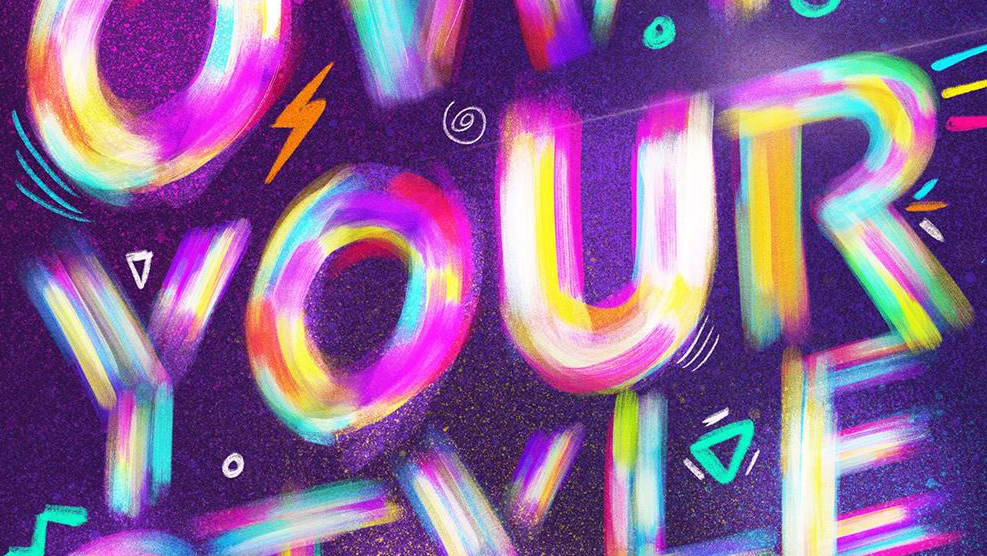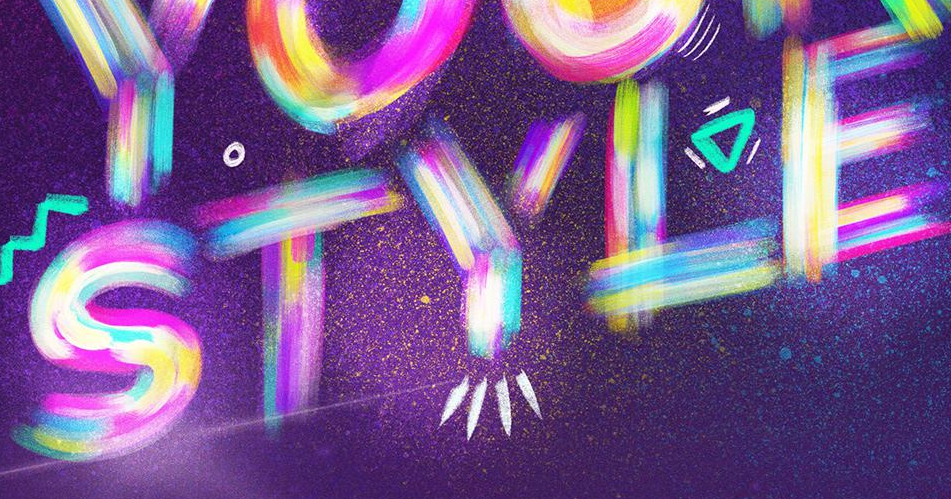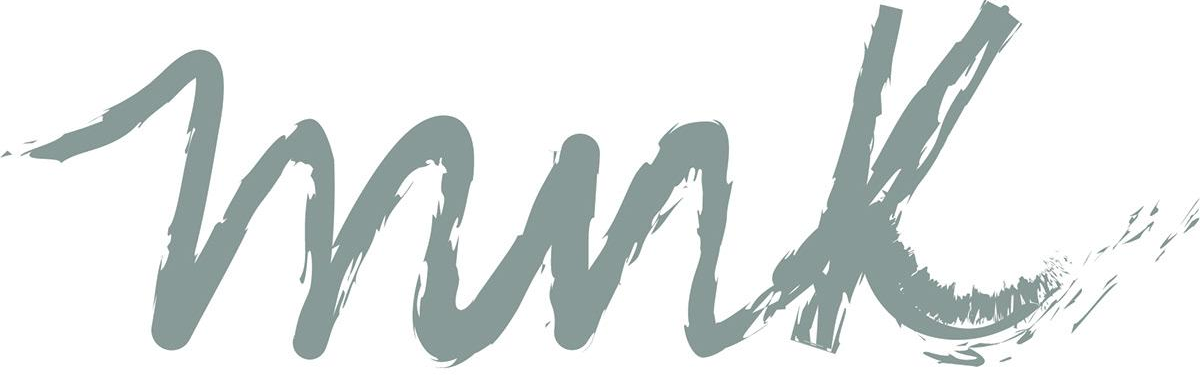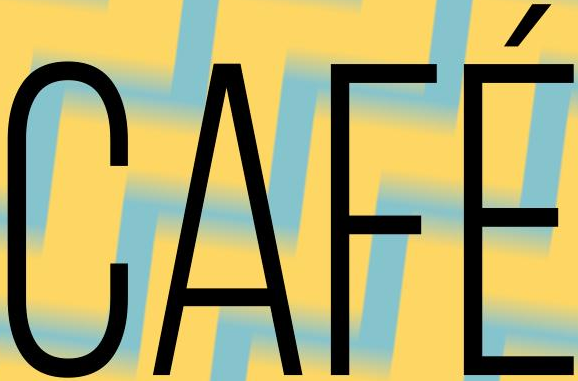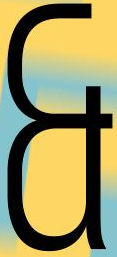Identify the words shown in these images in order, separated by a semicolon. YOUR; STYLE; mnk; CAFÉ; & 